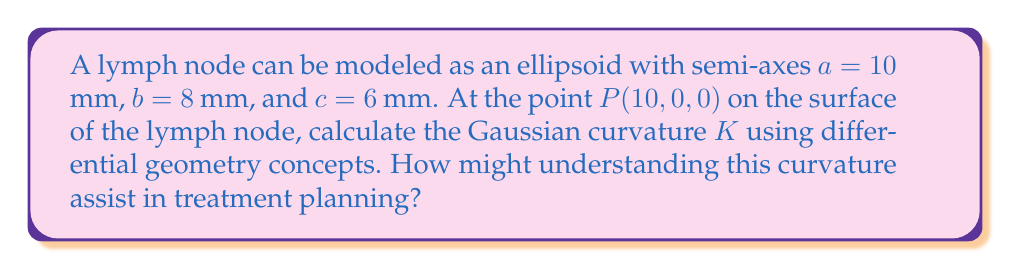What is the answer to this math problem? To calculate the Gaussian curvature of an ellipsoid at a given point, we'll follow these steps:

1) The ellipsoid equation is:
   $$\frac{x^2}{a^2} + \frac{y^2}{b^2} + \frac{z^2}{c^2} = 1$$

2) At point $P(10, 0, 0)$, we need to calculate the principal curvatures $k_1$ and $k_2$.

3) For an ellipsoid, the principal curvatures at any point $(x, y, z)$ are given by:
   $$k_1 = \frac{abc}{(b^2c^2x^2 + a^2c^2y^2 + a^2b^2z^2)^{3/2}} \cdot \frac{b^2c^2}{a^4}$$
   $$k_2 = \frac{abc}{(b^2c^2x^2 + a^2c^2y^2 + a^2b^2z^2)^{3/2}} \cdot \frac{c^2}{a^2}$$

4) At $P(10, 0, 0)$, we have:
   $$k_1 = \frac{10 \cdot 8 \cdot 6}{(8^2 \cdot 6^2 \cdot 10^2)^{3/2}} \cdot \frac{8^2 \cdot 6^2}{10^4} = \frac{480}{10^3 \cdot 48^{3/2}} \cdot \frac{2304}{10000} = \frac{1105920}{10000 \cdot 10^3 \cdot 48^{3/2}}$$
   $$k_2 = \frac{10 \cdot 8 \cdot 6}{(8^2 \cdot 6^2 \cdot 10^2)^{3/2}} \cdot \frac{6^2}{10^2} = \frac{480}{10^3 \cdot 48^{3/2}} \cdot \frac{36}{100} = \frac{17280}{100 \cdot 10^3 \cdot 48^{3/2}}$$

5) The Gaussian curvature $K$ is the product of the principal curvatures:
   $$K = k_1 \cdot k_2 = \frac{1105920}{10000 \cdot 10^3 \cdot 48^{3/2}} \cdot \frac{17280}{100 \cdot 10^3 \cdot 48^{3/2}} = \frac{19110297600}{10^9 \cdot 10^6 \cdot 48^3} = \frac{19110297600}{110592 \cdot 10^{15}} \approx 0.000173 \text{ mm}^{-2}$$

Understanding this curvature can assist in treatment planning by:
1) Helping to model the lymph node's shape accurately for targeted radiation therapy.
2) Assisting in predicting how the lymph node might respond to treatment or swell during the course of the disease.
3) Aiding in the development of more precise imaging techniques for monitoring lymph node changes.
Answer: $K \approx 0.000173 \text{ mm}^{-2}$ 